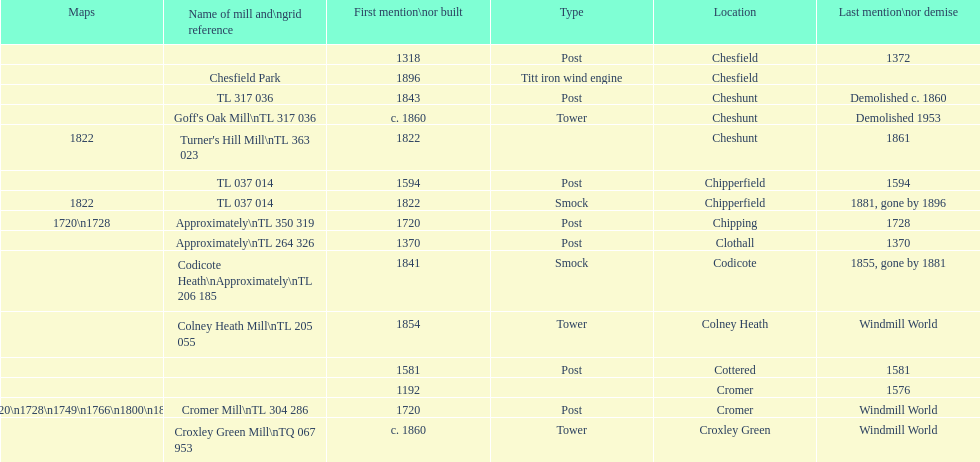What location has the most maps? Cromer. 